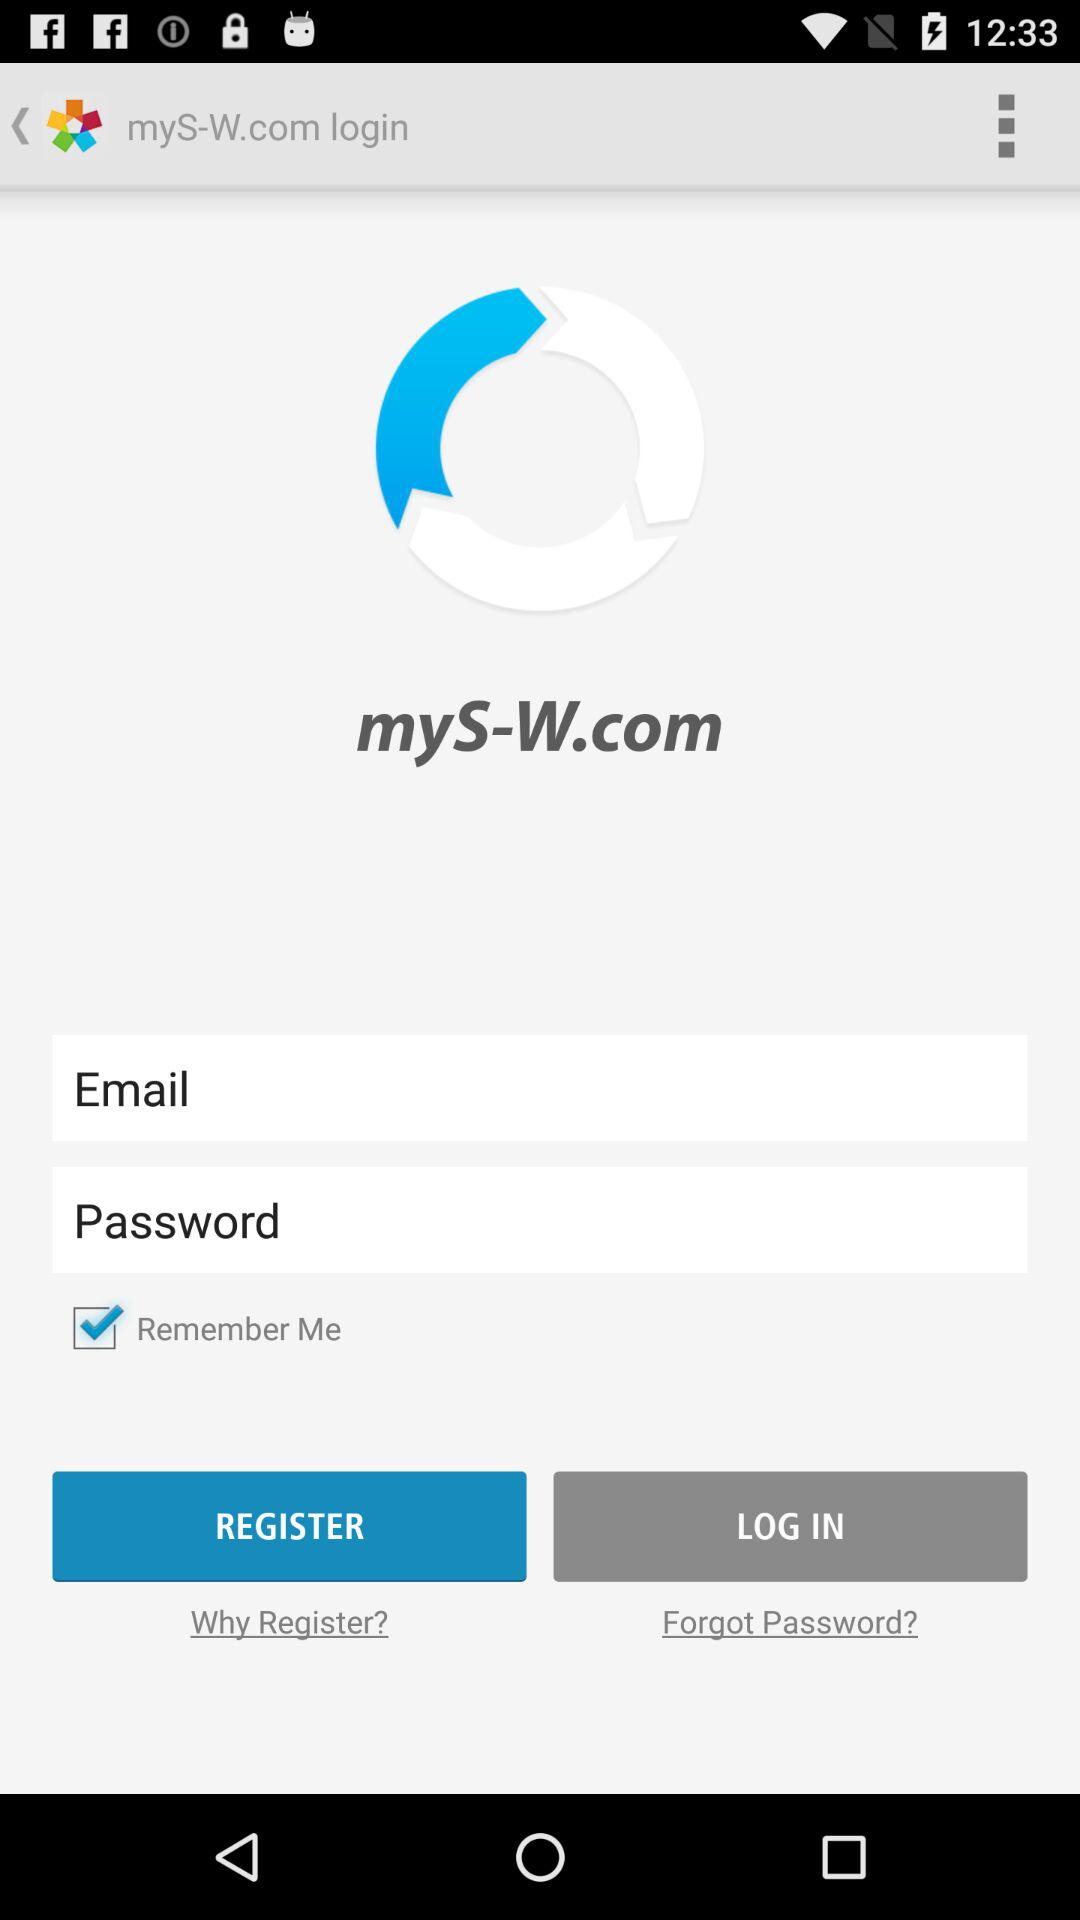What is the selected checkbox? The selected checkbox is "Remember Me". 